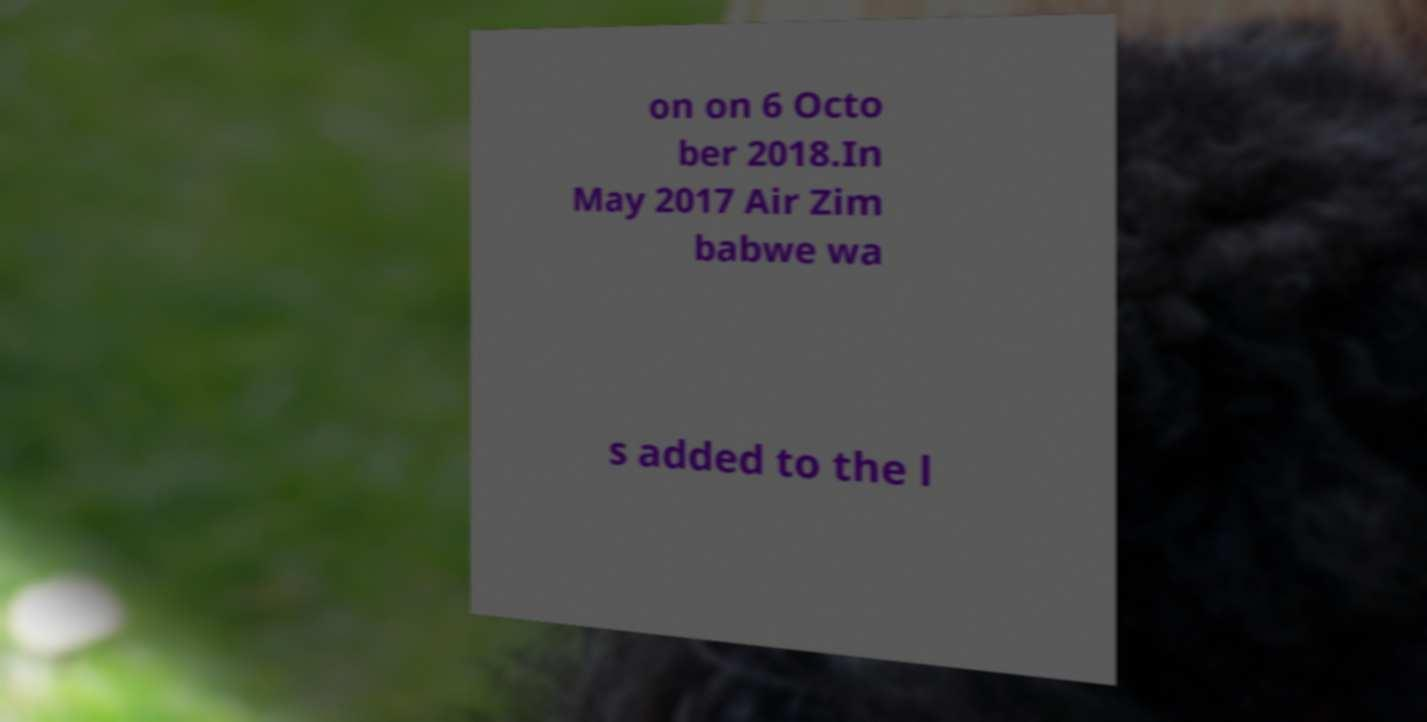Could you assist in decoding the text presented in this image and type it out clearly? on on 6 Octo ber 2018.In May 2017 Air Zim babwe wa s added to the l 